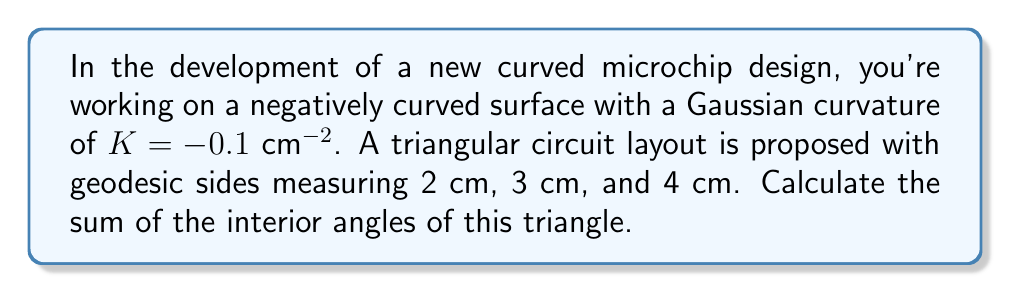Solve this math problem. To solve this problem, we'll use the Gauss-Bonnet theorem, which relates the geometry of a surface to its topology. For a geodesic triangle on a surface with Gaussian curvature $K$, the theorem states:

$$\alpha + \beta + \gamma = \pi - \int\int_A K dA$$

Where $\alpha$, $\beta$, and $\gamma$ are the interior angles of the triangle, and $A$ is the area of the triangle.

Steps:
1) First, we need to find the area of the triangle. We can use Heron's formula:

   $s = \frac{a+b+c}{2} = \frac{2+3+4}{2} = 4.5$ cm

   $A = \sqrt{s(s-a)(s-b)(s-c)}$
   $= \sqrt{4.5(4.5-2)(4.5-3)(4.5-4)}$
   $= \sqrt{4.5 \cdot 2.5 \cdot 1.5 \cdot 0.5}$
   $= \sqrt{8.4375}$
   $\approx 2.9047$ cm^2

2) Now we can apply the Gauss-Bonnet theorem:

   $\alpha + \beta + \gamma = \pi - \int\int_A K dA$

3) Since $K$ is constant, we can simplify:

   $\alpha + \beta + \gamma = \pi - KA$

4) Substituting the values:

   $\alpha + \beta + \gamma = \pi - (-0.1 \text{ cm}^{-2})(2.9047 \text{ cm}^2)$
   $= \pi + 0.29047$

5) Convert to degrees:

   $(\pi + 0.29047) \cdot \frac{180°}{\pi} \approx 196.64°$
Answer: 196.64° 